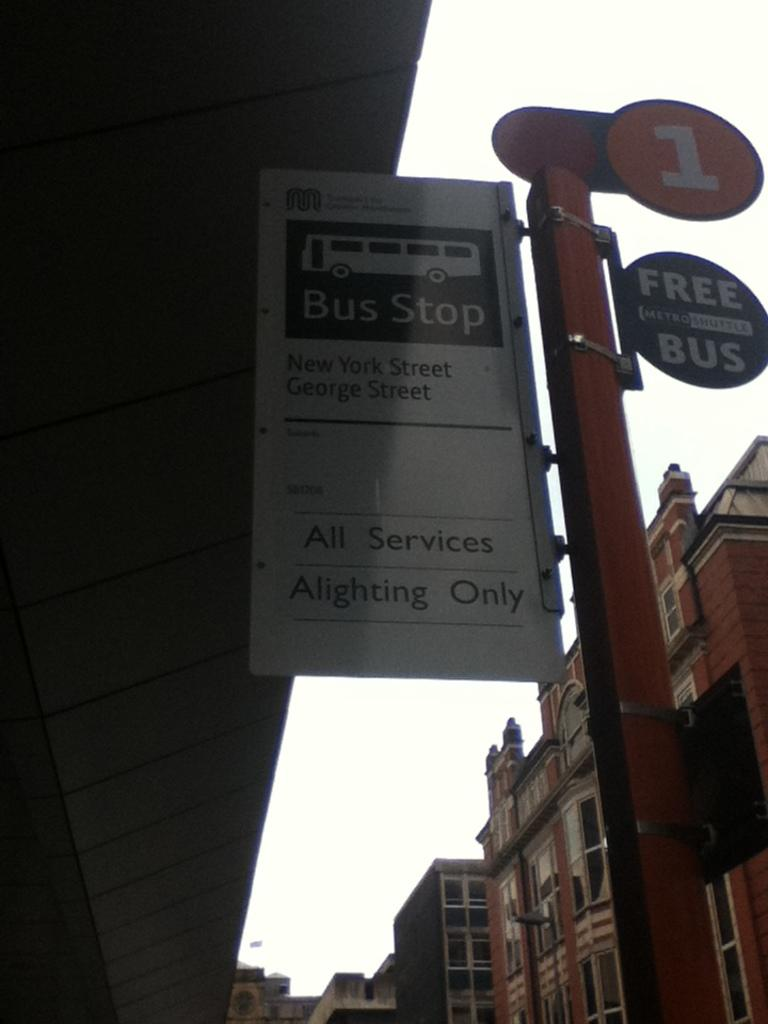What is located on the right side of the image? There is a pole on the right side of the image. What is attached to the pole? There are three boards fixed to the pole. What can be seen in the background of the image? The sky is visible in the background of the image. What type of structures are present on the right side of the image? There are buildings on the right side of the image. How many moons can be seen in the image? There is no moon visible in the image; only the sky is visible in the background. What is the number of people visible in the image? There is no information about people in the provided facts, so we cannot determine the number of people in the image. 